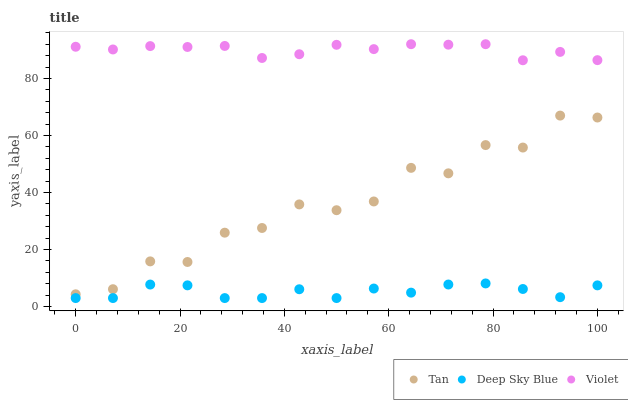Does Deep Sky Blue have the minimum area under the curve?
Answer yes or no. Yes. Does Violet have the maximum area under the curve?
Answer yes or no. Yes. Does Violet have the minimum area under the curve?
Answer yes or no. No. Does Deep Sky Blue have the maximum area under the curve?
Answer yes or no. No. Is Violet the smoothest?
Answer yes or no. Yes. Is Tan the roughest?
Answer yes or no. Yes. Is Deep Sky Blue the smoothest?
Answer yes or no. No. Is Deep Sky Blue the roughest?
Answer yes or no. No. Does Deep Sky Blue have the lowest value?
Answer yes or no. Yes. Does Violet have the lowest value?
Answer yes or no. No. Does Violet have the highest value?
Answer yes or no. Yes. Does Deep Sky Blue have the highest value?
Answer yes or no. No. Is Deep Sky Blue less than Tan?
Answer yes or no. Yes. Is Tan greater than Deep Sky Blue?
Answer yes or no. Yes. Does Deep Sky Blue intersect Tan?
Answer yes or no. No. 